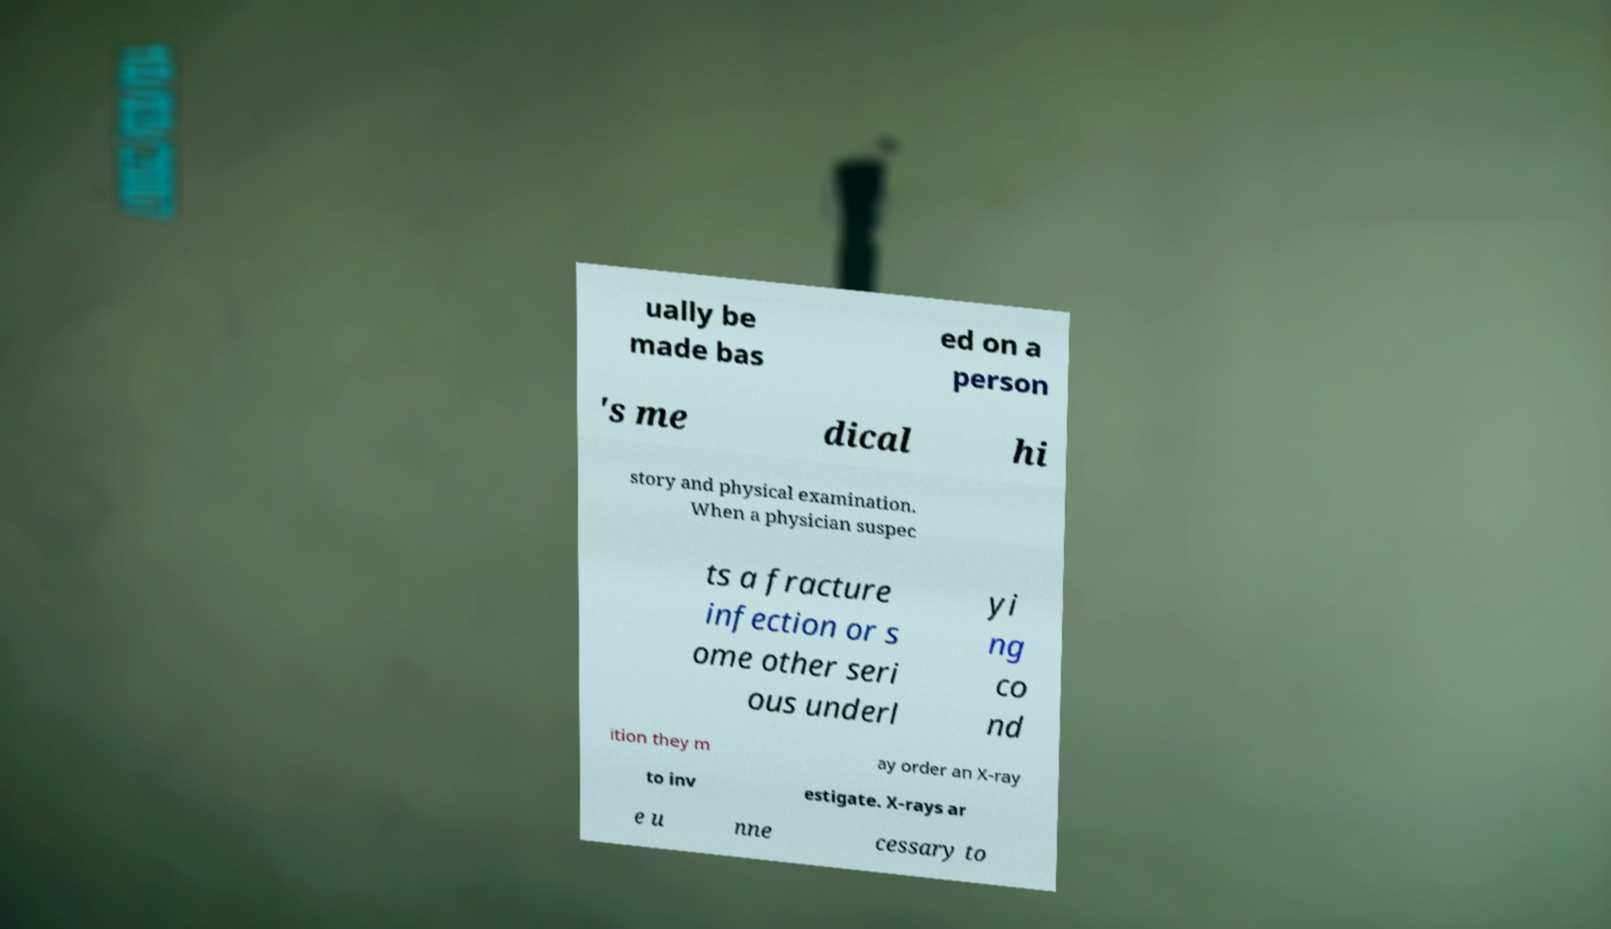What messages or text are displayed in this image? I need them in a readable, typed format. ually be made bas ed on a person 's me dical hi story and physical examination. When a physician suspec ts a fracture infection or s ome other seri ous underl yi ng co nd ition they m ay order an X-ray to inv estigate. X-rays ar e u nne cessary to 